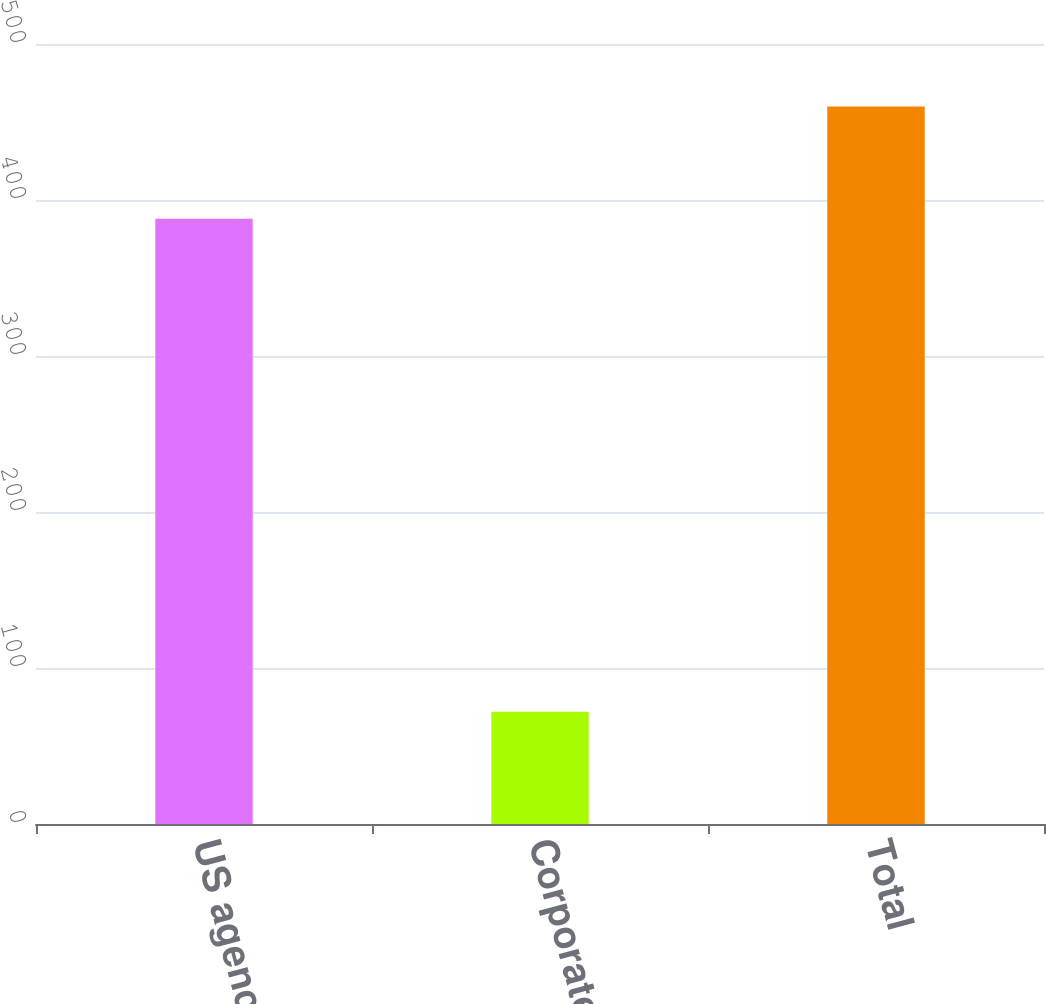Convert chart. <chart><loc_0><loc_0><loc_500><loc_500><bar_chart><fcel>US agency securities<fcel>Corporate bonds<fcel>Total<nl><fcel>388<fcel>72<fcel>460<nl></chart> 